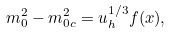<formula> <loc_0><loc_0><loc_500><loc_500>m _ { 0 } ^ { 2 } - m _ { 0 c } ^ { 2 } = u _ { h } ^ { 1 / 3 } f ( x ) ,</formula> 